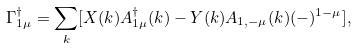Convert formula to latex. <formula><loc_0><loc_0><loc_500><loc_500>\Gamma ^ { \dagger } _ { 1 \mu } = \sum _ { k } [ X ( k ) A ^ { \dagger } _ { 1 \mu } ( k ) - Y ( k ) A _ { 1 , - \mu } ( k ) ( - ) ^ { 1 - \mu } ] ,</formula> 